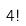Convert formula to latex. <formula><loc_0><loc_0><loc_500><loc_500>4 !</formula> 